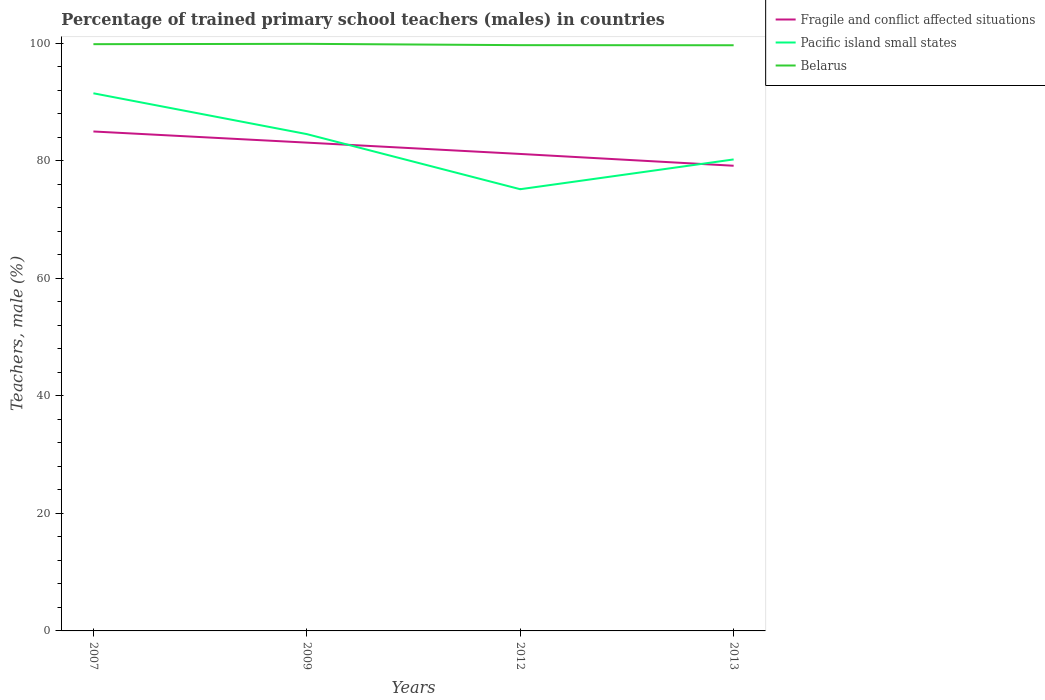Does the line corresponding to Pacific island small states intersect with the line corresponding to Fragile and conflict affected situations?
Your answer should be very brief. Yes. Across all years, what is the maximum percentage of trained primary school teachers (males) in Pacific island small states?
Offer a terse response. 75.14. In which year was the percentage of trained primary school teachers (males) in Fragile and conflict affected situations maximum?
Make the answer very short. 2013. What is the total percentage of trained primary school teachers (males) in Belarus in the graph?
Provide a succinct answer. 0.18. What is the difference between the highest and the second highest percentage of trained primary school teachers (males) in Belarus?
Offer a very short reply. 0.24. Is the percentage of trained primary school teachers (males) in Belarus strictly greater than the percentage of trained primary school teachers (males) in Pacific island small states over the years?
Make the answer very short. No. How many lines are there?
Your answer should be compact. 3. How many years are there in the graph?
Your answer should be compact. 4. Does the graph contain grids?
Keep it short and to the point. No. Where does the legend appear in the graph?
Provide a short and direct response. Top right. What is the title of the graph?
Give a very brief answer. Percentage of trained primary school teachers (males) in countries. What is the label or title of the X-axis?
Give a very brief answer. Years. What is the label or title of the Y-axis?
Make the answer very short. Teachers, male (%). What is the Teachers, male (%) of Fragile and conflict affected situations in 2007?
Keep it short and to the point. 84.96. What is the Teachers, male (%) in Pacific island small states in 2007?
Offer a very short reply. 91.45. What is the Teachers, male (%) in Belarus in 2007?
Your answer should be very brief. 99.81. What is the Teachers, male (%) of Fragile and conflict affected situations in 2009?
Your response must be concise. 83.06. What is the Teachers, male (%) of Pacific island small states in 2009?
Provide a succinct answer. 84.51. What is the Teachers, male (%) in Belarus in 2009?
Offer a terse response. 99.87. What is the Teachers, male (%) in Fragile and conflict affected situations in 2012?
Offer a very short reply. 81.14. What is the Teachers, male (%) of Pacific island small states in 2012?
Keep it short and to the point. 75.14. What is the Teachers, male (%) of Belarus in 2012?
Provide a succinct answer. 99.64. What is the Teachers, male (%) in Fragile and conflict affected situations in 2013?
Your answer should be compact. 79.13. What is the Teachers, male (%) of Pacific island small states in 2013?
Your response must be concise. 80.2. What is the Teachers, male (%) in Belarus in 2013?
Make the answer very short. 99.63. Across all years, what is the maximum Teachers, male (%) of Fragile and conflict affected situations?
Your response must be concise. 84.96. Across all years, what is the maximum Teachers, male (%) in Pacific island small states?
Provide a succinct answer. 91.45. Across all years, what is the maximum Teachers, male (%) in Belarus?
Provide a succinct answer. 99.87. Across all years, what is the minimum Teachers, male (%) of Fragile and conflict affected situations?
Give a very brief answer. 79.13. Across all years, what is the minimum Teachers, male (%) of Pacific island small states?
Ensure brevity in your answer.  75.14. Across all years, what is the minimum Teachers, male (%) of Belarus?
Give a very brief answer. 99.63. What is the total Teachers, male (%) of Fragile and conflict affected situations in the graph?
Keep it short and to the point. 328.29. What is the total Teachers, male (%) in Pacific island small states in the graph?
Make the answer very short. 331.3. What is the total Teachers, male (%) in Belarus in the graph?
Your answer should be very brief. 398.94. What is the difference between the Teachers, male (%) of Fragile and conflict affected situations in 2007 and that in 2009?
Your answer should be compact. 1.9. What is the difference between the Teachers, male (%) of Pacific island small states in 2007 and that in 2009?
Offer a terse response. 6.94. What is the difference between the Teachers, male (%) of Belarus in 2007 and that in 2009?
Your answer should be very brief. -0.06. What is the difference between the Teachers, male (%) in Fragile and conflict affected situations in 2007 and that in 2012?
Provide a succinct answer. 3.82. What is the difference between the Teachers, male (%) in Pacific island small states in 2007 and that in 2012?
Make the answer very short. 16.32. What is the difference between the Teachers, male (%) in Belarus in 2007 and that in 2012?
Offer a very short reply. 0.17. What is the difference between the Teachers, male (%) of Fragile and conflict affected situations in 2007 and that in 2013?
Your answer should be very brief. 5.83. What is the difference between the Teachers, male (%) in Pacific island small states in 2007 and that in 2013?
Your answer should be very brief. 11.25. What is the difference between the Teachers, male (%) in Belarus in 2007 and that in 2013?
Ensure brevity in your answer.  0.18. What is the difference between the Teachers, male (%) of Fragile and conflict affected situations in 2009 and that in 2012?
Your response must be concise. 1.93. What is the difference between the Teachers, male (%) in Pacific island small states in 2009 and that in 2012?
Keep it short and to the point. 9.37. What is the difference between the Teachers, male (%) in Belarus in 2009 and that in 2012?
Offer a terse response. 0.22. What is the difference between the Teachers, male (%) of Fragile and conflict affected situations in 2009 and that in 2013?
Provide a succinct answer. 3.93. What is the difference between the Teachers, male (%) in Pacific island small states in 2009 and that in 2013?
Give a very brief answer. 4.31. What is the difference between the Teachers, male (%) in Belarus in 2009 and that in 2013?
Keep it short and to the point. 0.24. What is the difference between the Teachers, male (%) in Fragile and conflict affected situations in 2012 and that in 2013?
Your response must be concise. 2.01. What is the difference between the Teachers, male (%) in Pacific island small states in 2012 and that in 2013?
Offer a terse response. -5.07. What is the difference between the Teachers, male (%) in Belarus in 2012 and that in 2013?
Keep it short and to the point. 0.02. What is the difference between the Teachers, male (%) of Fragile and conflict affected situations in 2007 and the Teachers, male (%) of Pacific island small states in 2009?
Make the answer very short. 0.45. What is the difference between the Teachers, male (%) of Fragile and conflict affected situations in 2007 and the Teachers, male (%) of Belarus in 2009?
Your answer should be compact. -14.91. What is the difference between the Teachers, male (%) in Pacific island small states in 2007 and the Teachers, male (%) in Belarus in 2009?
Provide a short and direct response. -8.41. What is the difference between the Teachers, male (%) in Fragile and conflict affected situations in 2007 and the Teachers, male (%) in Pacific island small states in 2012?
Provide a succinct answer. 9.82. What is the difference between the Teachers, male (%) in Fragile and conflict affected situations in 2007 and the Teachers, male (%) in Belarus in 2012?
Your response must be concise. -14.68. What is the difference between the Teachers, male (%) of Pacific island small states in 2007 and the Teachers, male (%) of Belarus in 2012?
Your answer should be compact. -8.19. What is the difference between the Teachers, male (%) of Fragile and conflict affected situations in 2007 and the Teachers, male (%) of Pacific island small states in 2013?
Keep it short and to the point. 4.76. What is the difference between the Teachers, male (%) in Fragile and conflict affected situations in 2007 and the Teachers, male (%) in Belarus in 2013?
Make the answer very short. -14.67. What is the difference between the Teachers, male (%) of Pacific island small states in 2007 and the Teachers, male (%) of Belarus in 2013?
Keep it short and to the point. -8.17. What is the difference between the Teachers, male (%) in Fragile and conflict affected situations in 2009 and the Teachers, male (%) in Pacific island small states in 2012?
Your answer should be very brief. 7.93. What is the difference between the Teachers, male (%) of Fragile and conflict affected situations in 2009 and the Teachers, male (%) of Belarus in 2012?
Provide a short and direct response. -16.58. What is the difference between the Teachers, male (%) in Pacific island small states in 2009 and the Teachers, male (%) in Belarus in 2012?
Keep it short and to the point. -15.13. What is the difference between the Teachers, male (%) of Fragile and conflict affected situations in 2009 and the Teachers, male (%) of Pacific island small states in 2013?
Give a very brief answer. 2.86. What is the difference between the Teachers, male (%) of Fragile and conflict affected situations in 2009 and the Teachers, male (%) of Belarus in 2013?
Your response must be concise. -16.56. What is the difference between the Teachers, male (%) in Pacific island small states in 2009 and the Teachers, male (%) in Belarus in 2013?
Your answer should be compact. -15.12. What is the difference between the Teachers, male (%) in Fragile and conflict affected situations in 2012 and the Teachers, male (%) in Pacific island small states in 2013?
Make the answer very short. 0.93. What is the difference between the Teachers, male (%) of Fragile and conflict affected situations in 2012 and the Teachers, male (%) of Belarus in 2013?
Make the answer very short. -18.49. What is the difference between the Teachers, male (%) in Pacific island small states in 2012 and the Teachers, male (%) in Belarus in 2013?
Your answer should be very brief. -24.49. What is the average Teachers, male (%) in Fragile and conflict affected situations per year?
Provide a succinct answer. 82.07. What is the average Teachers, male (%) of Pacific island small states per year?
Your answer should be compact. 82.83. What is the average Teachers, male (%) in Belarus per year?
Your response must be concise. 99.74. In the year 2007, what is the difference between the Teachers, male (%) of Fragile and conflict affected situations and Teachers, male (%) of Pacific island small states?
Make the answer very short. -6.5. In the year 2007, what is the difference between the Teachers, male (%) of Fragile and conflict affected situations and Teachers, male (%) of Belarus?
Your response must be concise. -14.85. In the year 2007, what is the difference between the Teachers, male (%) in Pacific island small states and Teachers, male (%) in Belarus?
Ensure brevity in your answer.  -8.35. In the year 2009, what is the difference between the Teachers, male (%) in Fragile and conflict affected situations and Teachers, male (%) in Pacific island small states?
Your answer should be very brief. -1.45. In the year 2009, what is the difference between the Teachers, male (%) of Fragile and conflict affected situations and Teachers, male (%) of Belarus?
Your response must be concise. -16.8. In the year 2009, what is the difference between the Teachers, male (%) in Pacific island small states and Teachers, male (%) in Belarus?
Ensure brevity in your answer.  -15.35. In the year 2012, what is the difference between the Teachers, male (%) of Fragile and conflict affected situations and Teachers, male (%) of Pacific island small states?
Your response must be concise. 6. In the year 2012, what is the difference between the Teachers, male (%) in Fragile and conflict affected situations and Teachers, male (%) in Belarus?
Your answer should be compact. -18.51. In the year 2012, what is the difference between the Teachers, male (%) of Pacific island small states and Teachers, male (%) of Belarus?
Provide a short and direct response. -24.5. In the year 2013, what is the difference between the Teachers, male (%) in Fragile and conflict affected situations and Teachers, male (%) in Pacific island small states?
Keep it short and to the point. -1.07. In the year 2013, what is the difference between the Teachers, male (%) of Fragile and conflict affected situations and Teachers, male (%) of Belarus?
Your answer should be very brief. -20.5. In the year 2013, what is the difference between the Teachers, male (%) of Pacific island small states and Teachers, male (%) of Belarus?
Keep it short and to the point. -19.42. What is the ratio of the Teachers, male (%) in Fragile and conflict affected situations in 2007 to that in 2009?
Give a very brief answer. 1.02. What is the ratio of the Teachers, male (%) in Pacific island small states in 2007 to that in 2009?
Provide a succinct answer. 1.08. What is the ratio of the Teachers, male (%) of Belarus in 2007 to that in 2009?
Your answer should be very brief. 1. What is the ratio of the Teachers, male (%) of Fragile and conflict affected situations in 2007 to that in 2012?
Offer a terse response. 1.05. What is the ratio of the Teachers, male (%) in Pacific island small states in 2007 to that in 2012?
Your answer should be compact. 1.22. What is the ratio of the Teachers, male (%) in Belarus in 2007 to that in 2012?
Ensure brevity in your answer.  1. What is the ratio of the Teachers, male (%) of Fragile and conflict affected situations in 2007 to that in 2013?
Provide a short and direct response. 1.07. What is the ratio of the Teachers, male (%) of Pacific island small states in 2007 to that in 2013?
Your response must be concise. 1.14. What is the ratio of the Teachers, male (%) of Belarus in 2007 to that in 2013?
Give a very brief answer. 1. What is the ratio of the Teachers, male (%) in Fragile and conflict affected situations in 2009 to that in 2012?
Keep it short and to the point. 1.02. What is the ratio of the Teachers, male (%) in Pacific island small states in 2009 to that in 2012?
Your response must be concise. 1.12. What is the ratio of the Teachers, male (%) in Belarus in 2009 to that in 2012?
Your response must be concise. 1. What is the ratio of the Teachers, male (%) of Fragile and conflict affected situations in 2009 to that in 2013?
Keep it short and to the point. 1.05. What is the ratio of the Teachers, male (%) of Pacific island small states in 2009 to that in 2013?
Give a very brief answer. 1.05. What is the ratio of the Teachers, male (%) of Belarus in 2009 to that in 2013?
Your response must be concise. 1. What is the ratio of the Teachers, male (%) of Fragile and conflict affected situations in 2012 to that in 2013?
Your answer should be compact. 1.03. What is the ratio of the Teachers, male (%) of Pacific island small states in 2012 to that in 2013?
Give a very brief answer. 0.94. What is the ratio of the Teachers, male (%) in Belarus in 2012 to that in 2013?
Ensure brevity in your answer.  1. What is the difference between the highest and the second highest Teachers, male (%) of Fragile and conflict affected situations?
Your answer should be very brief. 1.9. What is the difference between the highest and the second highest Teachers, male (%) of Pacific island small states?
Ensure brevity in your answer.  6.94. What is the difference between the highest and the second highest Teachers, male (%) of Belarus?
Your answer should be very brief. 0.06. What is the difference between the highest and the lowest Teachers, male (%) in Fragile and conflict affected situations?
Provide a short and direct response. 5.83. What is the difference between the highest and the lowest Teachers, male (%) in Pacific island small states?
Provide a succinct answer. 16.32. What is the difference between the highest and the lowest Teachers, male (%) of Belarus?
Offer a very short reply. 0.24. 